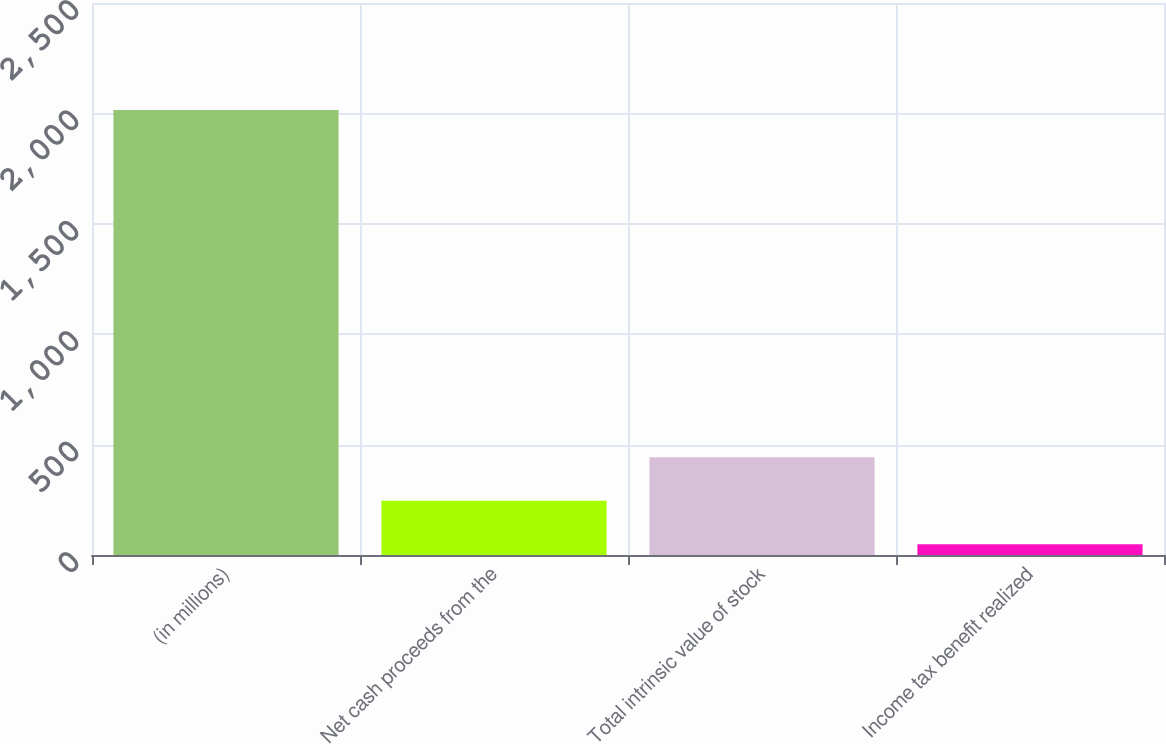Convert chart. <chart><loc_0><loc_0><loc_500><loc_500><bar_chart><fcel>(in millions)<fcel>Net cash proceeds from the<fcel>Total intrinsic value of stock<fcel>Income tax benefit realized<nl><fcel>2015<fcel>245.6<fcel>442.2<fcel>49<nl></chart> 